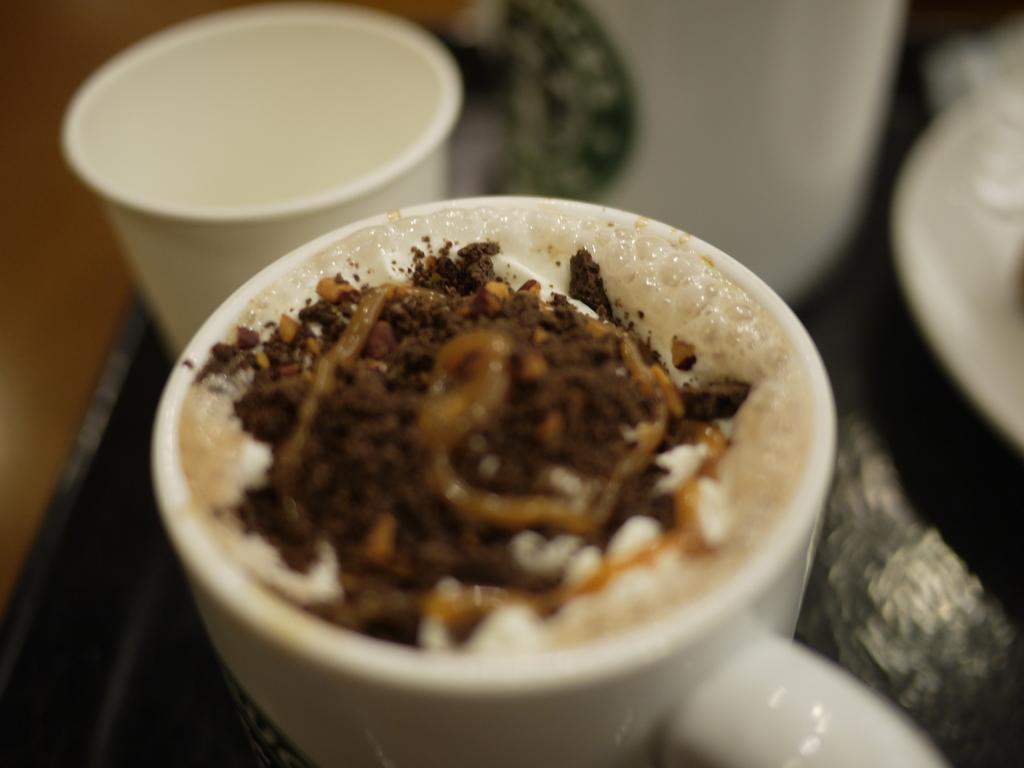Can you describe this image briefly? In this picture we can see few cups on the table and we can find drink in the cup. 